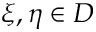Convert formula to latex. <formula><loc_0><loc_0><loc_500><loc_500>\xi , \eta \in D</formula> 